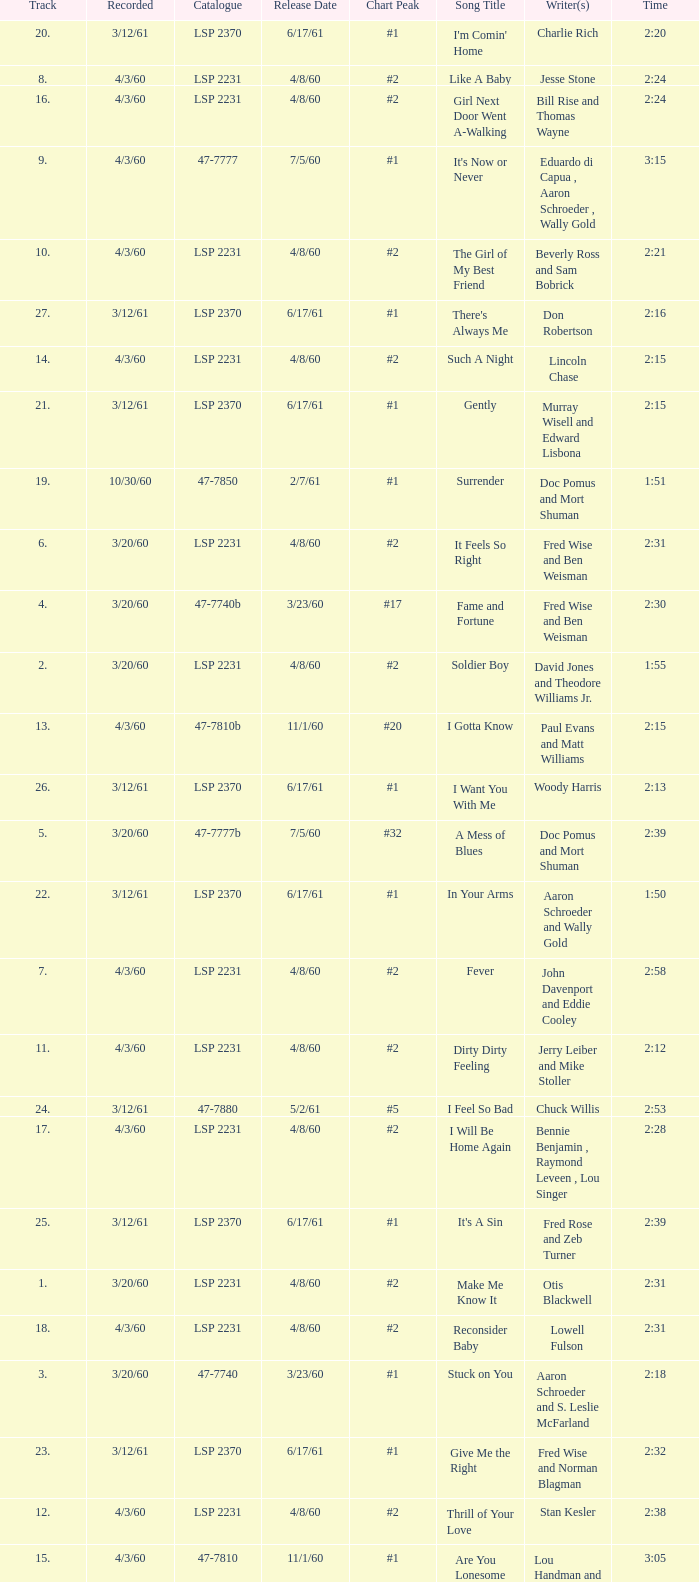On songs with track numbers smaller than number 17 and catalogues of LSP 2231, who are the writer(s)? Otis Blackwell, David Jones and Theodore Williams Jr., Fred Wise and Ben Weisman, John Davenport and Eddie Cooley, Jesse Stone, Beverly Ross and Sam Bobrick, Jerry Leiber and Mike Stoller, Stan Kesler, Lincoln Chase, Bill Rise and Thomas Wayne. 